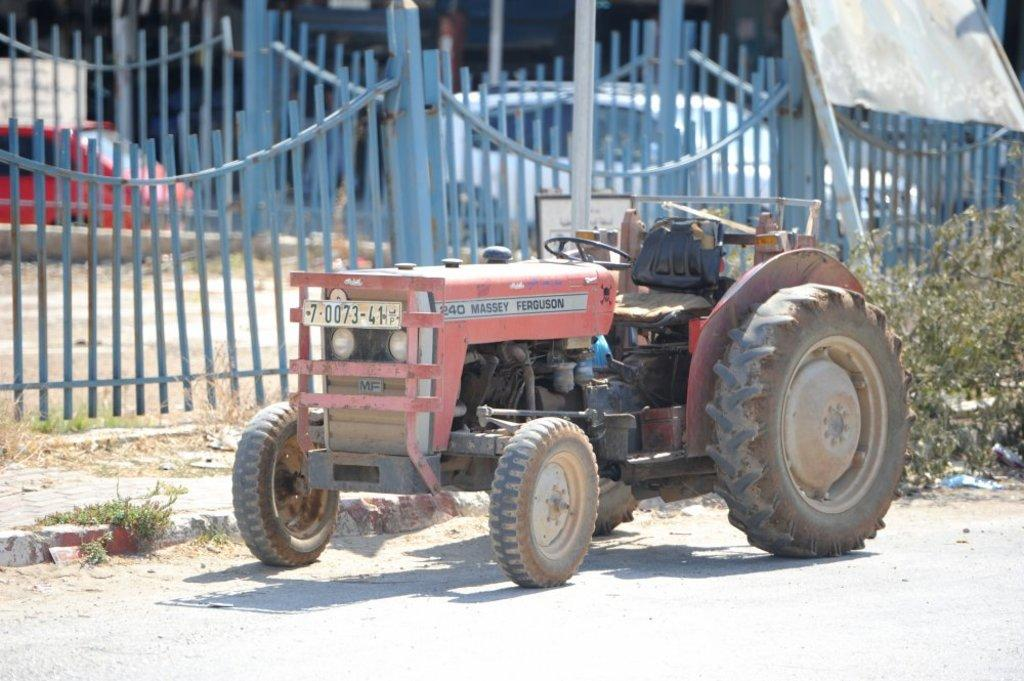What is the main subject of the image? There is a vehicle on the road in the image. What can be seen near the vehicle? There is railing visible in the image. Are there any other vehicles in the image? Yes, there are other vehicles in the image. What type of vegetation can be seen in the image? There are plants with a green color in the image. What committee is responsible for the exchange of the vehicles in the image? There is no committee or exchange of vehicles mentioned in the image; it simply shows a vehicle on the road with other vehicles nearby. 